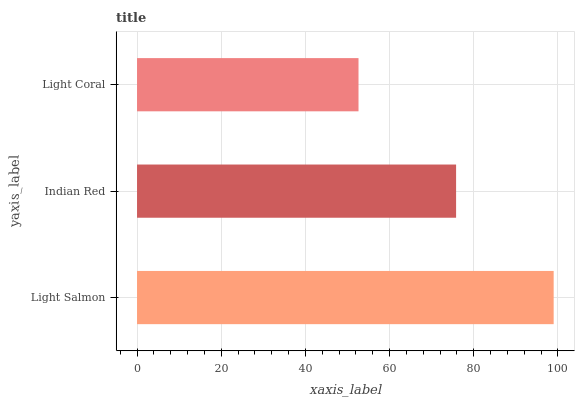Is Light Coral the minimum?
Answer yes or no. Yes. Is Light Salmon the maximum?
Answer yes or no. Yes. Is Indian Red the minimum?
Answer yes or no. No. Is Indian Red the maximum?
Answer yes or no. No. Is Light Salmon greater than Indian Red?
Answer yes or no. Yes. Is Indian Red less than Light Salmon?
Answer yes or no. Yes. Is Indian Red greater than Light Salmon?
Answer yes or no. No. Is Light Salmon less than Indian Red?
Answer yes or no. No. Is Indian Red the high median?
Answer yes or no. Yes. Is Indian Red the low median?
Answer yes or no. Yes. Is Light Coral the high median?
Answer yes or no. No. Is Light Coral the low median?
Answer yes or no. No. 